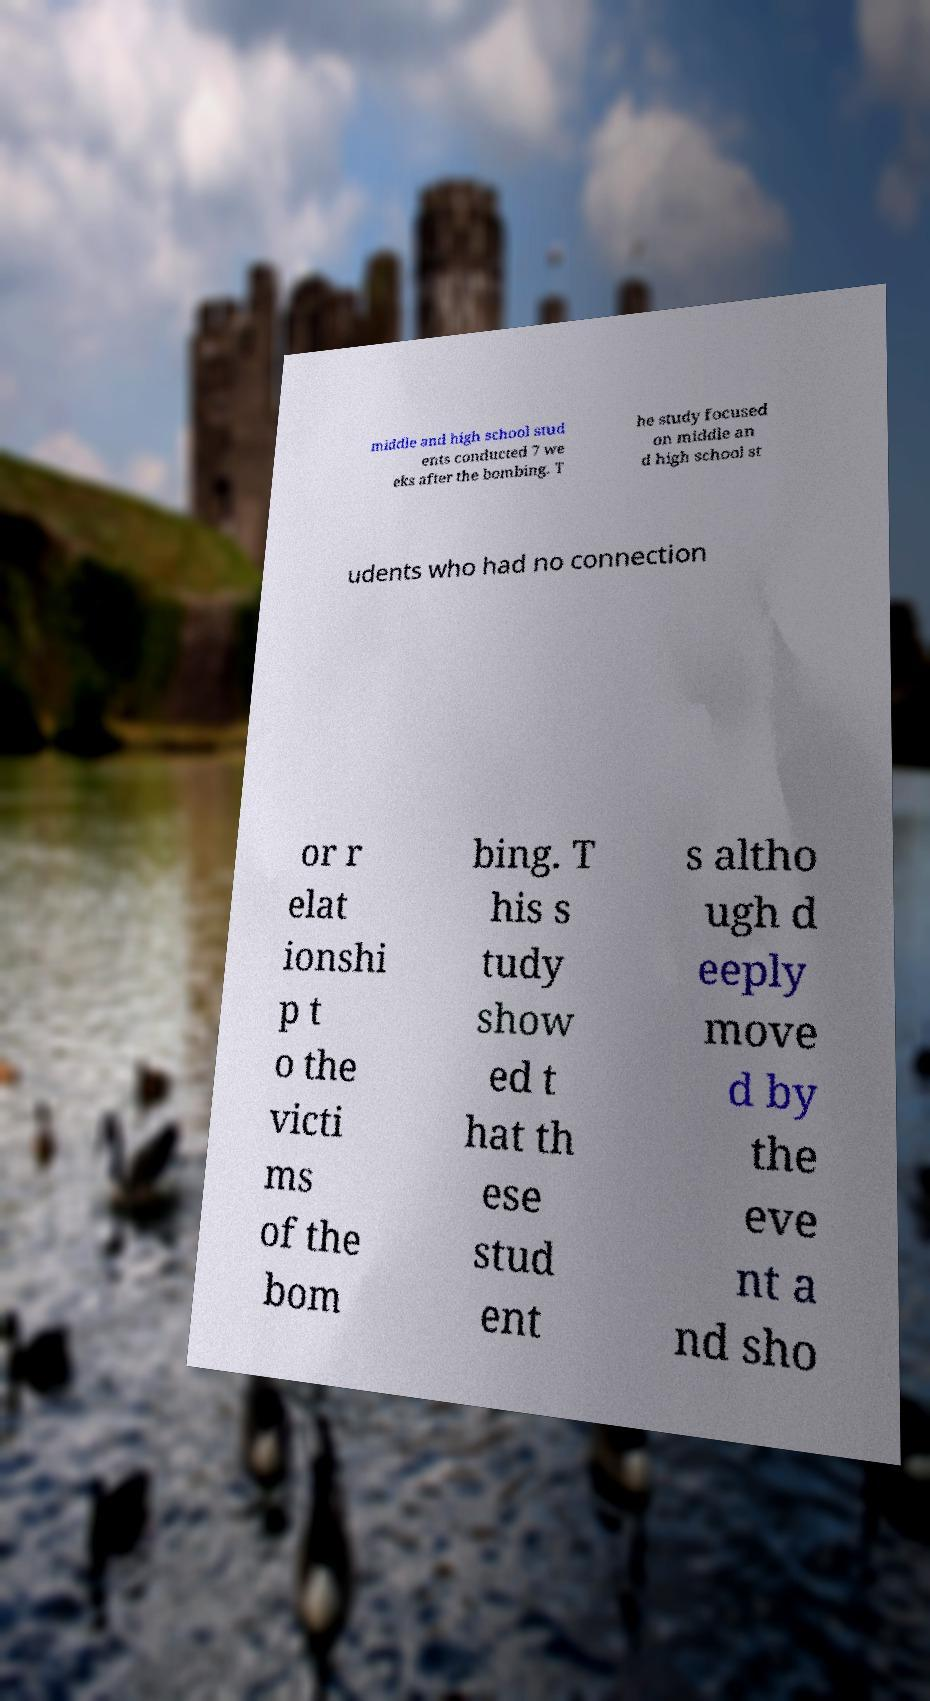Can you read and provide the text displayed in the image?This photo seems to have some interesting text. Can you extract and type it out for me? middle and high school stud ents conducted 7 we eks after the bombing. T he study focused on middle an d high school st udents who had no connection or r elat ionshi p t o the victi ms of the bom bing. T his s tudy show ed t hat th ese stud ent s altho ugh d eeply move d by the eve nt a nd sho 